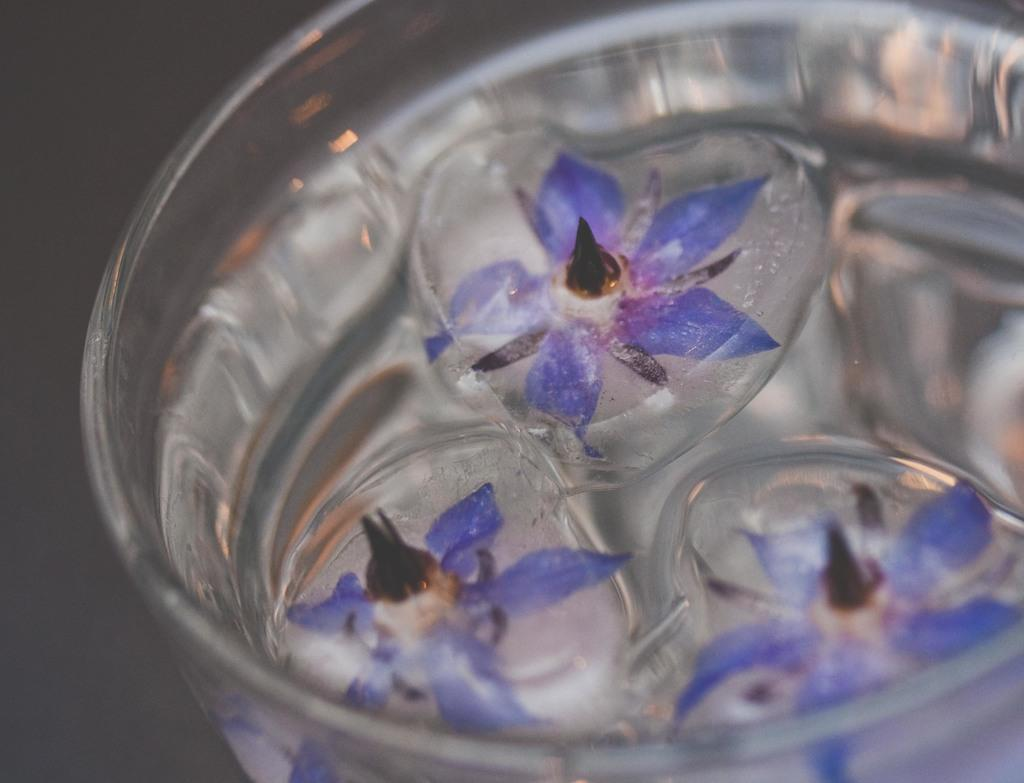What objects are present in the image that are typically associated with cold drinks? There are ice cubes in the image. What other objects can be seen in the image that are not typically associated with cold drinks? There are flowers in the image. How are the ice cubes and flowers arranged in the image? Both the ice cubes and flowers are in a glass. How many centimeters long is the bag in the image? There is no bag present in the image. What type of support is the ice cube using to stay afloat in the image? The ice cubes do not need any support to stay afloat in the image, as they are in a glass. 